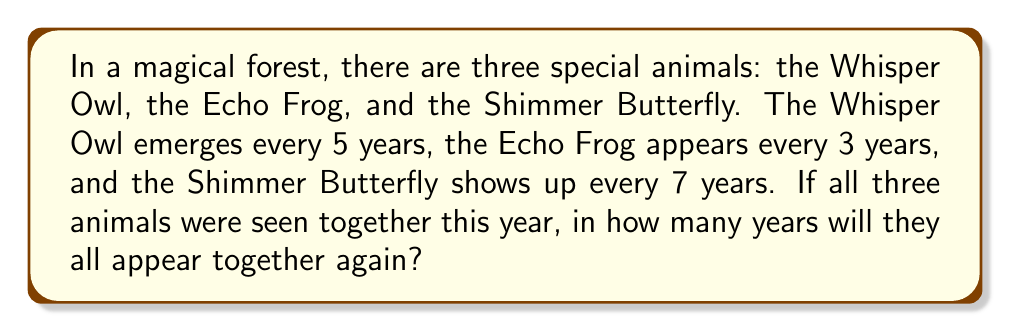Help me with this question. Let's approach this step-by-step using modular arithmetic:

1) We need to find the smallest number of years that is divisible by 5, 3, and 7.

2) In mathematical terms, we're looking for the least common multiple (LCM) of 5, 3, and 7.

3) To find the LCM, let's first find the prime factorization of each number:
   $5 = 5$
   $3 = 3$
   $7 = 7$

4) The LCM will include the highest power of each prime factor:
   $LCM = 5 \times 3 \times 7 = 105$

5) We can verify this using modular arithmetic:
   $105 \equiv 0 \pmod{5}$
   $105 \equiv 0 \pmod{3}$
   $105 \equiv 0 \pmod{7}$

6) This means that after 105 years, all three cycles will align again:
   $105 \div 5 = 21$ full cycles for the Whisper Owl
   $105 \div 3 = 35$ full cycles for the Echo Frog
   $105 \div 7 = 15$ full cycles for the Shimmer Butterfly

Therefore, all three animals will appear together again in 105 years.
Answer: 105 years 